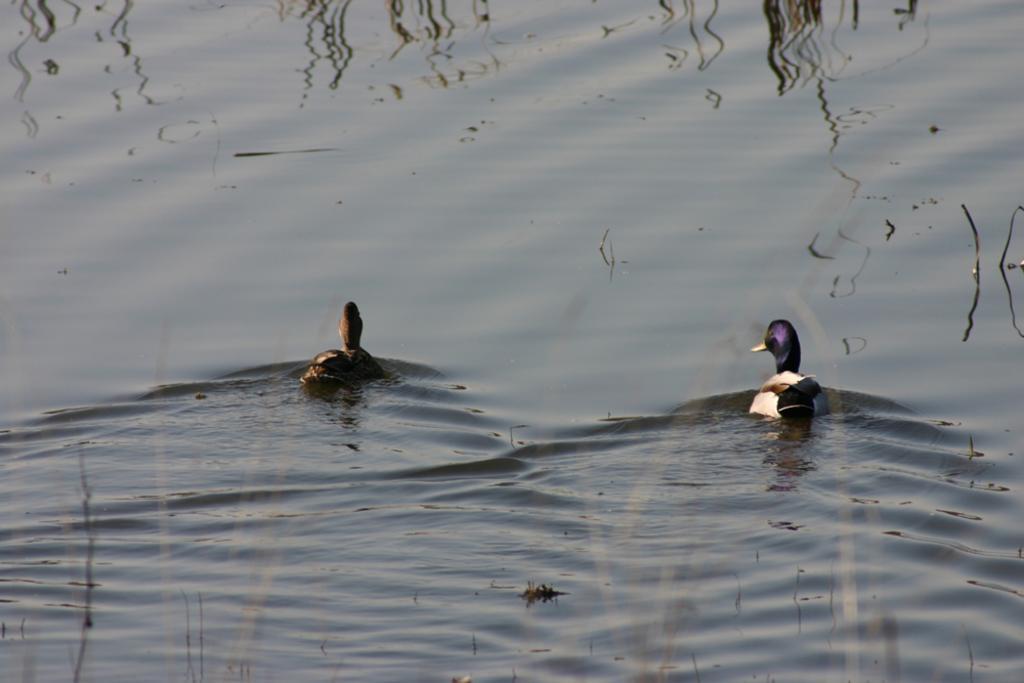Could you give a brief overview of what you see in this image? In this picture we can see the ducks are present on the water. In the background of the image we can see the shadow of the trees. 